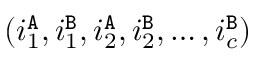Convert formula to latex. <formula><loc_0><loc_0><loc_500><loc_500>( i _ { 1 } ^ { \tt A } , i _ { 1 } ^ { \tt B } , i _ { 2 } ^ { \tt A } , i _ { 2 } ^ { \tt B } , \dots , i _ { c } ^ { \tt B } )</formula> 